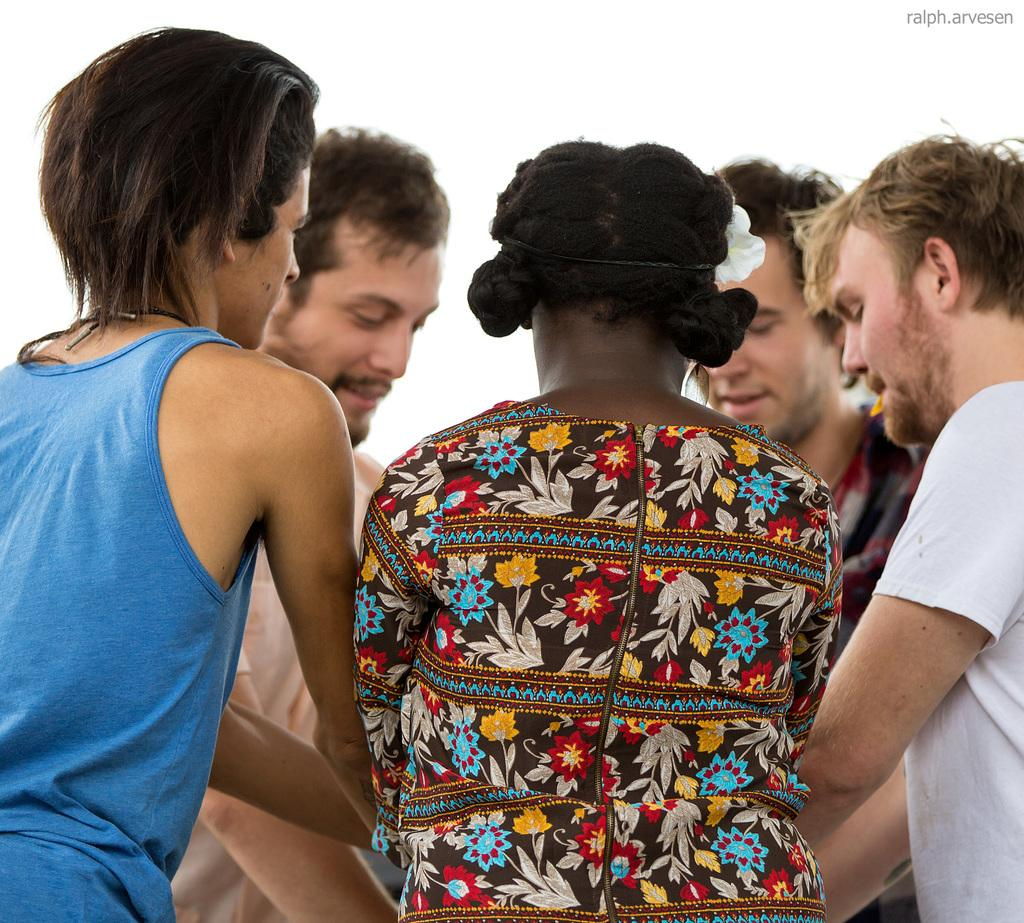What color is the background of the image? The background of the image is white. Is there any text or symbol in the image? Yes, there is a watermark in the top right corner of the image. Can you describe the main subject of the image? There is a group of people in the image. What type of coil is being used by the donkey in the image? There is no donkey or coil present in the image. What government policy is being discussed by the group of people in the image? The image does not provide any information about the conversation or topic being discussed by the group of people. 